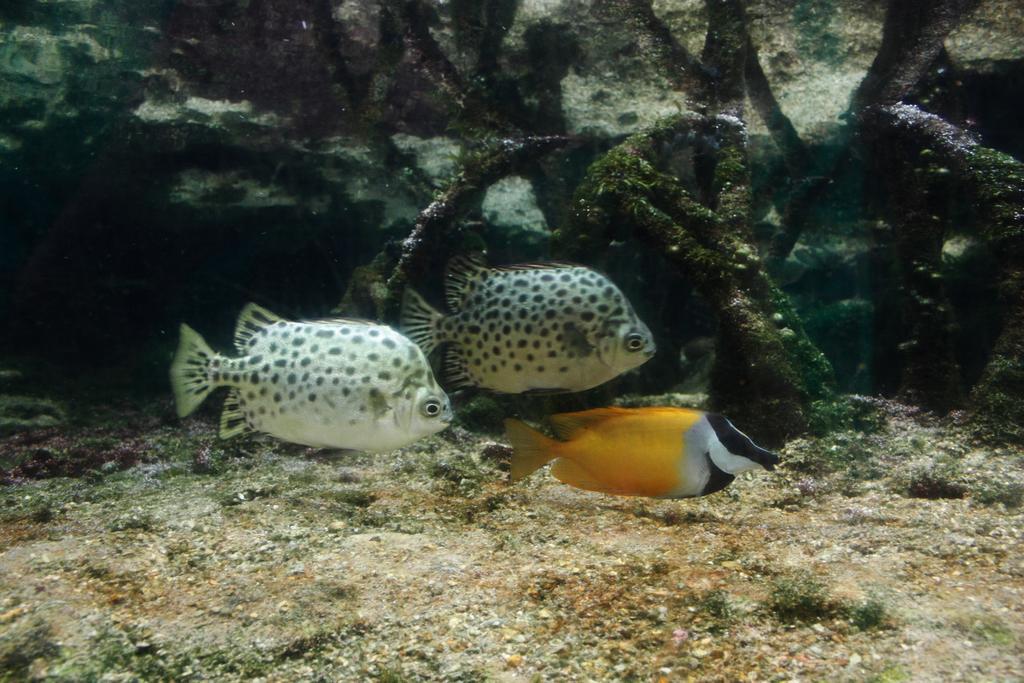Please provide a concise description of this image. There are beautiful white and black color fishes that are swimming in this water and there is a fish in golden black color in the water. 